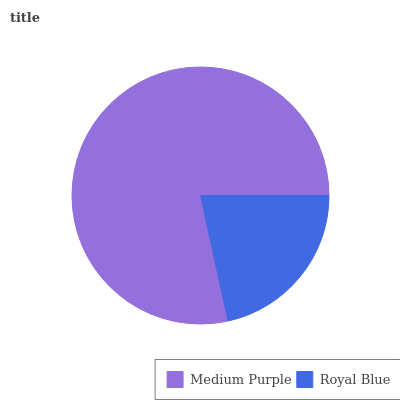Is Royal Blue the minimum?
Answer yes or no. Yes. Is Medium Purple the maximum?
Answer yes or no. Yes. Is Royal Blue the maximum?
Answer yes or no. No. Is Medium Purple greater than Royal Blue?
Answer yes or no. Yes. Is Royal Blue less than Medium Purple?
Answer yes or no. Yes. Is Royal Blue greater than Medium Purple?
Answer yes or no. No. Is Medium Purple less than Royal Blue?
Answer yes or no. No. Is Medium Purple the high median?
Answer yes or no. Yes. Is Royal Blue the low median?
Answer yes or no. Yes. Is Royal Blue the high median?
Answer yes or no. No. Is Medium Purple the low median?
Answer yes or no. No. 